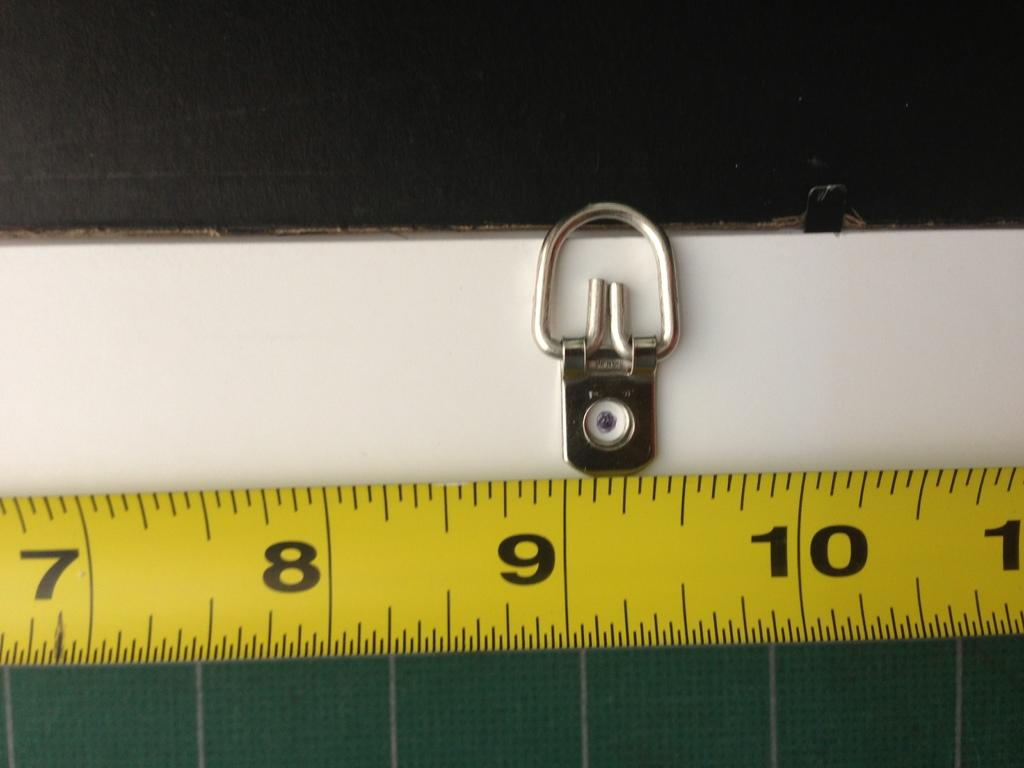How many inches is it to the silver item?
Give a very brief answer. 9. 